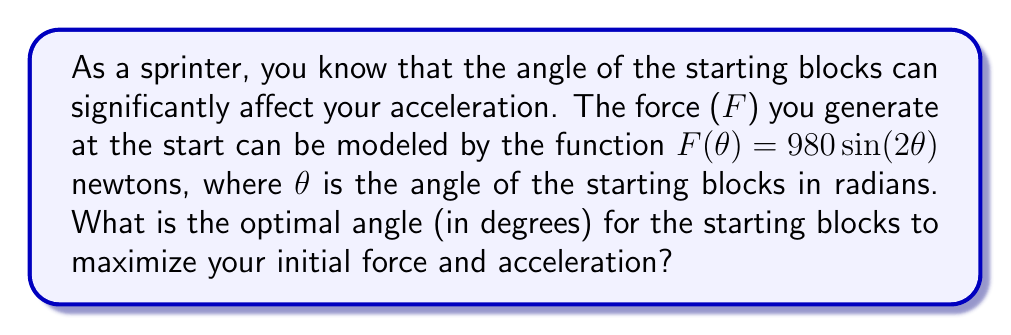Teach me how to tackle this problem. To find the optimal angle, we need to maximize the force function $F(\theta) = 980 \sin(2\theta)$. Let's approach this step-by-step:

1) The maximum value of sine occurs at $\frac{\pi}{2}$ radians or 90°.

2) For $\sin(2\theta)$ to be maximum, $2\theta$ should equal $\frac{\pi}{2}$.

3) Solving for $\theta$:
   $$2\theta = \frac{\pi}{2}$$
   $$\theta = \frac{\pi}{4}$$

4) Convert radians to degrees:
   $$\theta = \frac{\pi}{4} \cdot \frac{180°}{\pi} = 45°$$

5) Verify this is a maximum, not a minimum:
   The second derivative of $F(\theta)$ is $-3920 \sin(2\theta)$, which is negative when $\theta = 45°$, confirming a maximum.

Therefore, the optimal angle for the starting blocks is 45°.
Answer: 45° 